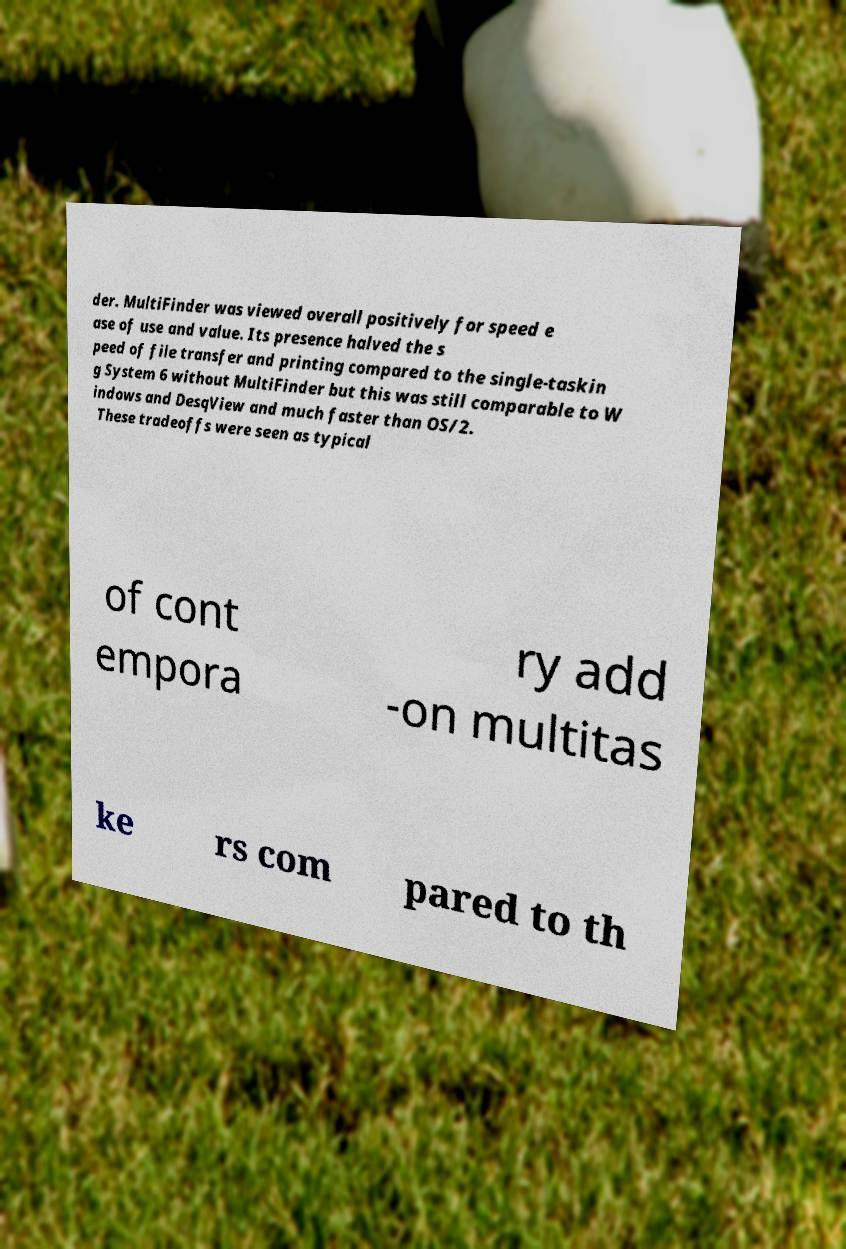There's text embedded in this image that I need extracted. Can you transcribe it verbatim? der. MultiFinder was viewed overall positively for speed e ase of use and value. Its presence halved the s peed of file transfer and printing compared to the single-taskin g System 6 without MultiFinder but this was still comparable to W indows and DesqView and much faster than OS/2. These tradeoffs were seen as typical of cont empora ry add -on multitas ke rs com pared to th 